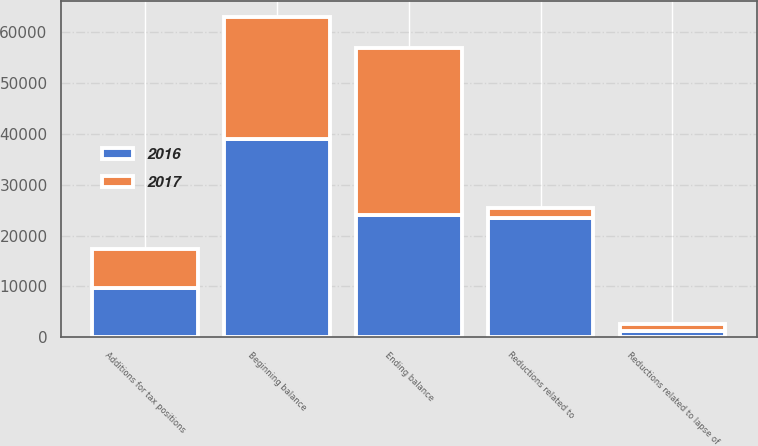<chart> <loc_0><loc_0><loc_500><loc_500><stacked_bar_chart><ecel><fcel>Beginning balance<fcel>Additions for tax positions<fcel>Reductions related to lapse of<fcel>Reductions related to<fcel>Ending balance<nl><fcel>2017<fcel>24066<fcel>7606<fcel>1380<fcel>2051<fcel>32776<nl><fcel>2016<fcel>39011<fcel>9714<fcel>1277<fcel>23382<fcel>24066<nl></chart> 